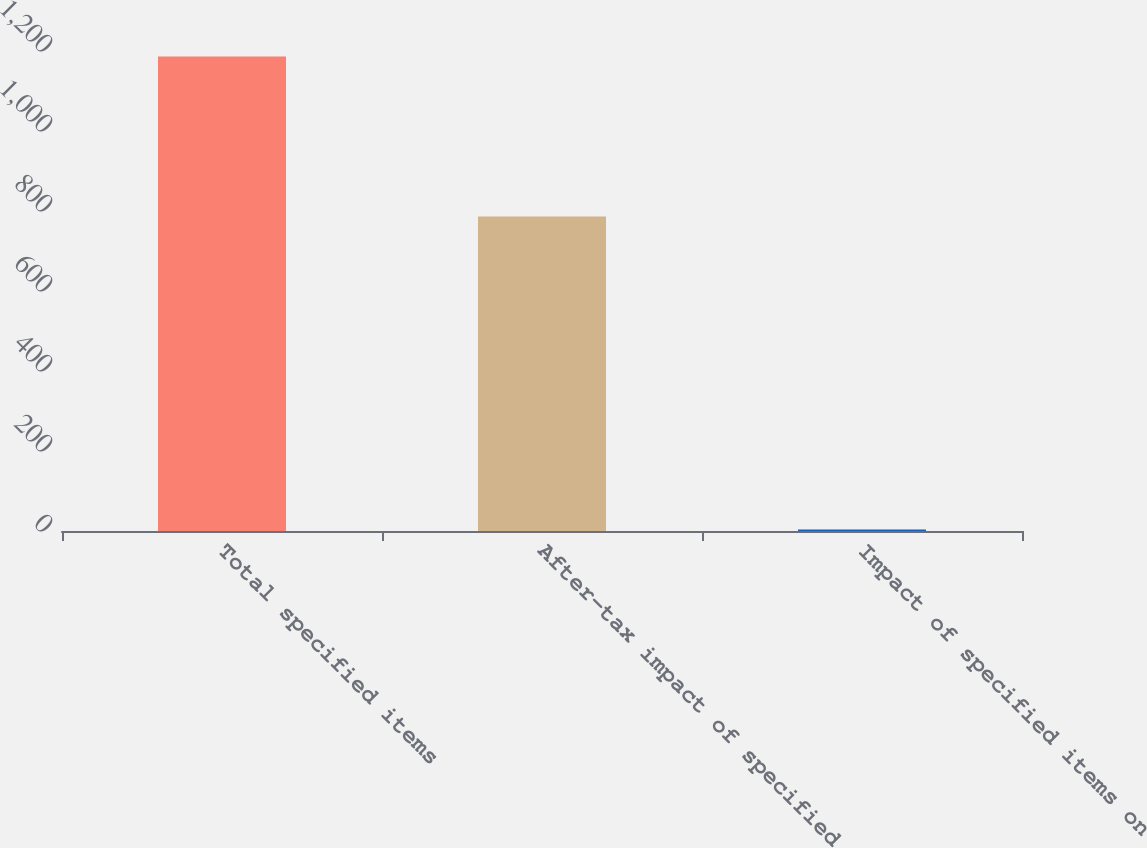<chart> <loc_0><loc_0><loc_500><loc_500><bar_chart><fcel>Total specified items<fcel>After-tax impact of specified<fcel>Impact of specified items on<nl><fcel>1186<fcel>786<fcel>3.79<nl></chart> 